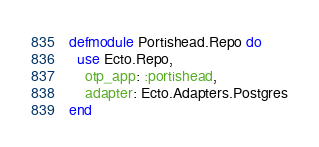<code> <loc_0><loc_0><loc_500><loc_500><_Elixir_>defmodule Portishead.Repo do
  use Ecto.Repo,
    otp_app: :portishead,
    adapter: Ecto.Adapters.Postgres
end
</code> 